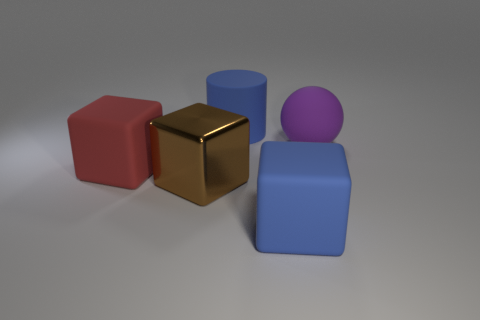Subtract all big blue blocks. How many blocks are left? 2 Add 4 metallic cubes. How many objects exist? 9 Subtract all gray blocks. Subtract all gray cylinders. How many blocks are left? 3 Subtract all cylinders. How many objects are left? 4 Add 2 big blue cylinders. How many big blue cylinders are left? 3 Add 4 blue things. How many blue things exist? 6 Subtract 0 gray balls. How many objects are left? 5 Subtract all cyan matte blocks. Subtract all large rubber things. How many objects are left? 1 